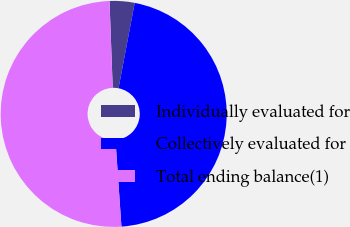Convert chart. <chart><loc_0><loc_0><loc_500><loc_500><pie_chart><fcel>Individually evaluated for<fcel>Collectively evaluated for<fcel>Total ending balance(1)<nl><fcel>3.57%<fcel>45.92%<fcel>50.51%<nl></chart> 